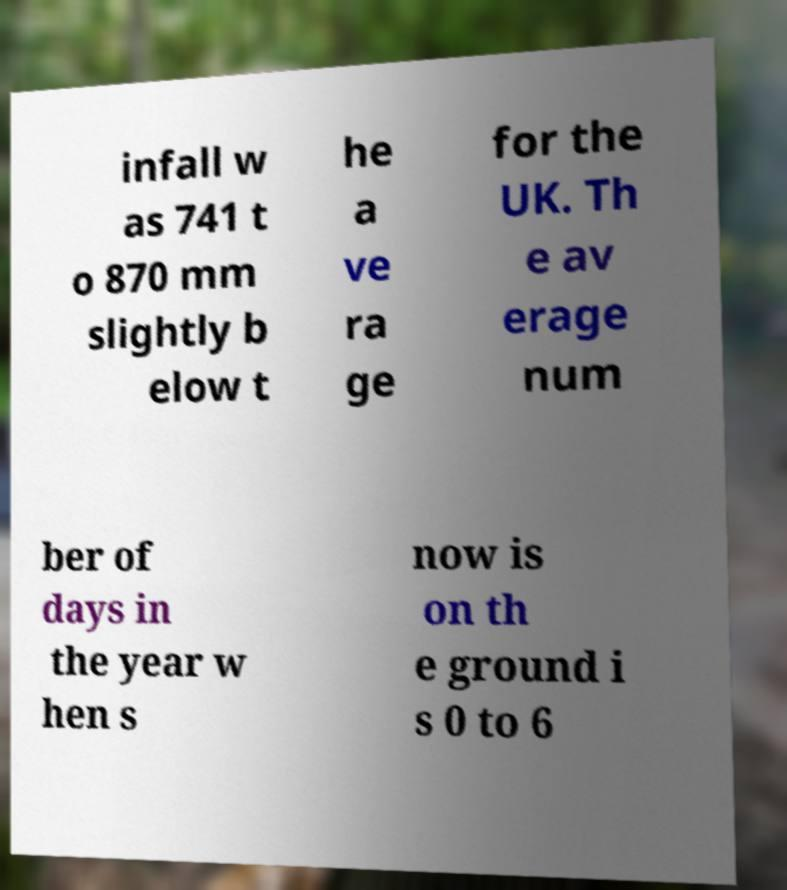What messages or text are displayed in this image? I need them in a readable, typed format. infall w as 741 t o 870 mm slightly b elow t he a ve ra ge for the UK. Th e av erage num ber of days in the year w hen s now is on th e ground i s 0 to 6 